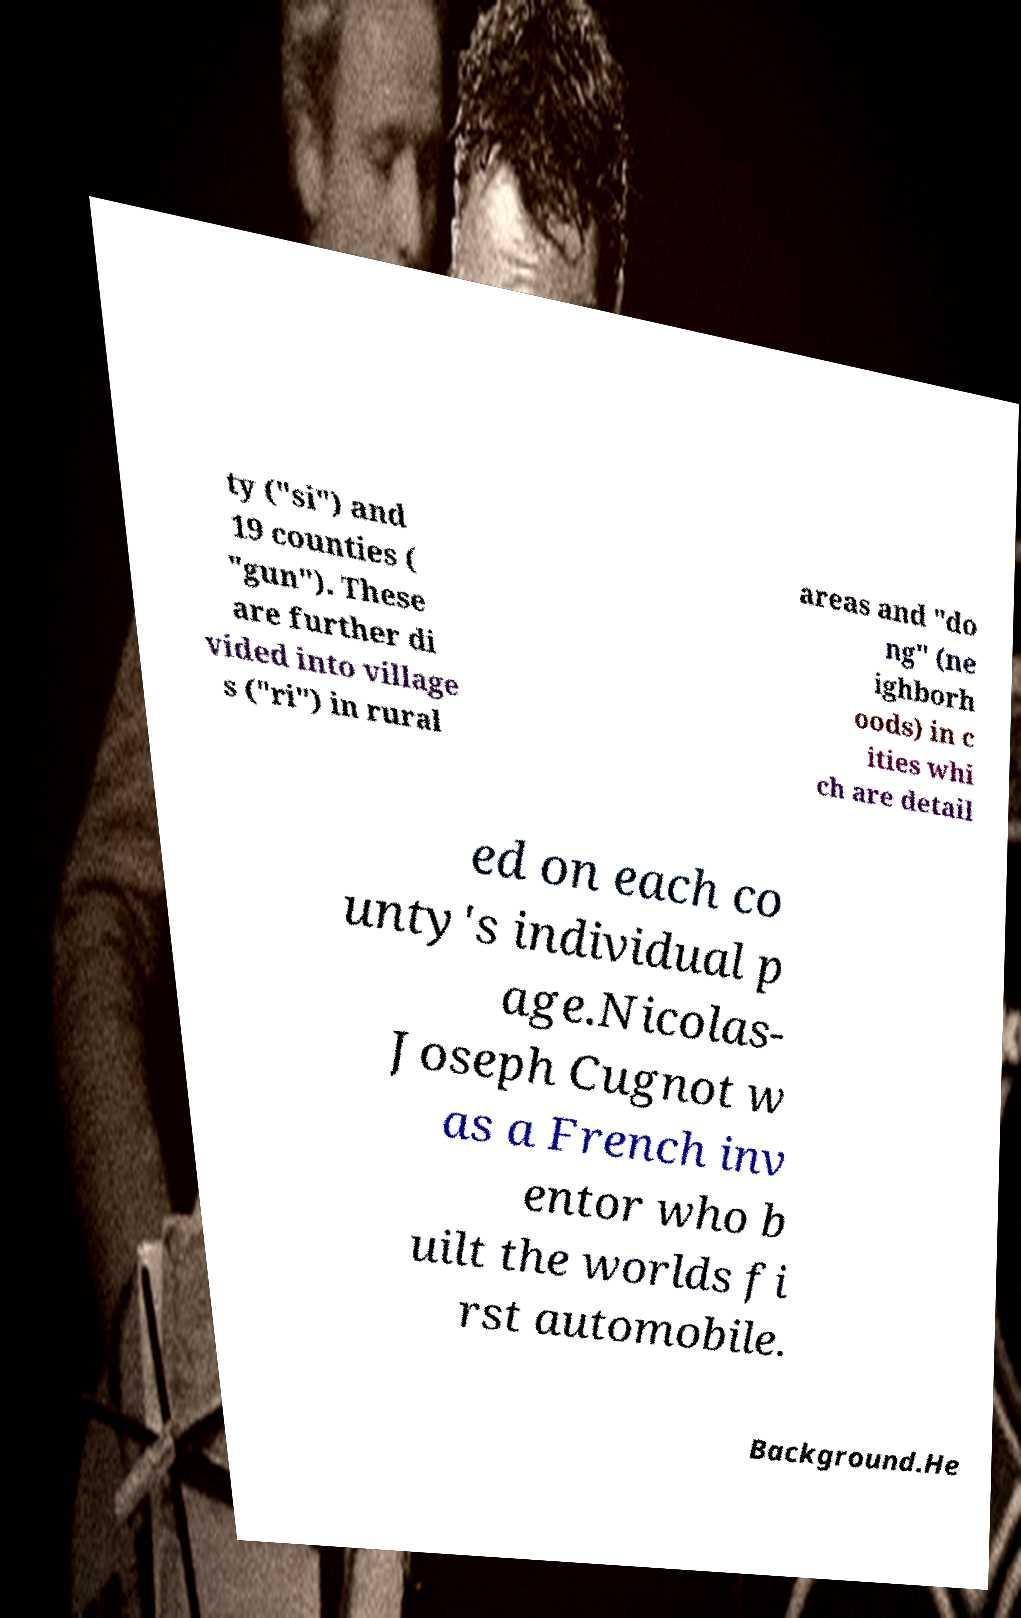I need the written content from this picture converted into text. Can you do that? ty ("si") and 19 counties ( "gun"). These are further di vided into village s ("ri") in rural areas and "do ng" (ne ighborh oods) in c ities whi ch are detail ed on each co unty's individual p age.Nicolas- Joseph Cugnot w as a French inv entor who b uilt the worlds fi rst automobile. Background.He 